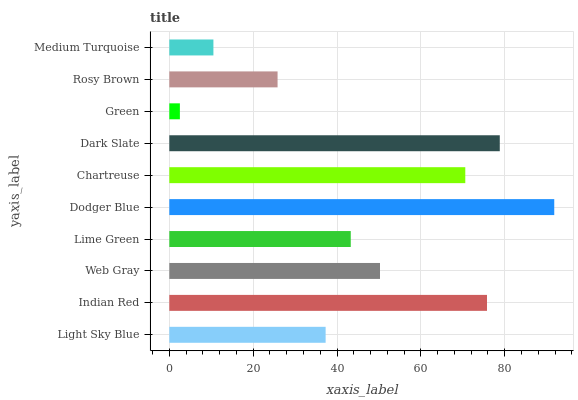Is Green the minimum?
Answer yes or no. Yes. Is Dodger Blue the maximum?
Answer yes or no. Yes. Is Indian Red the minimum?
Answer yes or no. No. Is Indian Red the maximum?
Answer yes or no. No. Is Indian Red greater than Light Sky Blue?
Answer yes or no. Yes. Is Light Sky Blue less than Indian Red?
Answer yes or no. Yes. Is Light Sky Blue greater than Indian Red?
Answer yes or no. No. Is Indian Red less than Light Sky Blue?
Answer yes or no. No. Is Web Gray the high median?
Answer yes or no. Yes. Is Lime Green the low median?
Answer yes or no. Yes. Is Medium Turquoise the high median?
Answer yes or no. No. Is Chartreuse the low median?
Answer yes or no. No. 